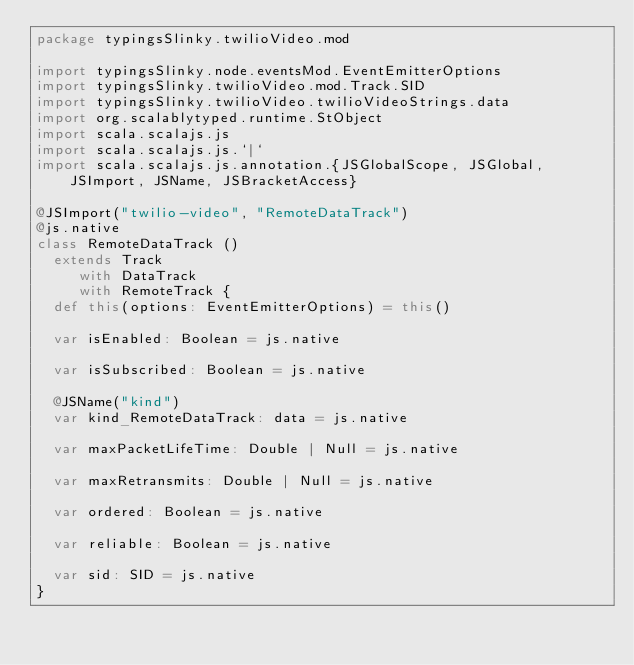<code> <loc_0><loc_0><loc_500><loc_500><_Scala_>package typingsSlinky.twilioVideo.mod

import typingsSlinky.node.eventsMod.EventEmitterOptions
import typingsSlinky.twilioVideo.mod.Track.SID
import typingsSlinky.twilioVideo.twilioVideoStrings.data
import org.scalablytyped.runtime.StObject
import scala.scalajs.js
import scala.scalajs.js.`|`
import scala.scalajs.js.annotation.{JSGlobalScope, JSGlobal, JSImport, JSName, JSBracketAccess}

@JSImport("twilio-video", "RemoteDataTrack")
@js.native
class RemoteDataTrack ()
  extends Track
     with DataTrack
     with RemoteTrack {
  def this(options: EventEmitterOptions) = this()
  
  var isEnabled: Boolean = js.native
  
  var isSubscribed: Boolean = js.native
  
  @JSName("kind")
  var kind_RemoteDataTrack: data = js.native
  
  var maxPacketLifeTime: Double | Null = js.native
  
  var maxRetransmits: Double | Null = js.native
  
  var ordered: Boolean = js.native
  
  var reliable: Boolean = js.native
  
  var sid: SID = js.native
}
</code> 